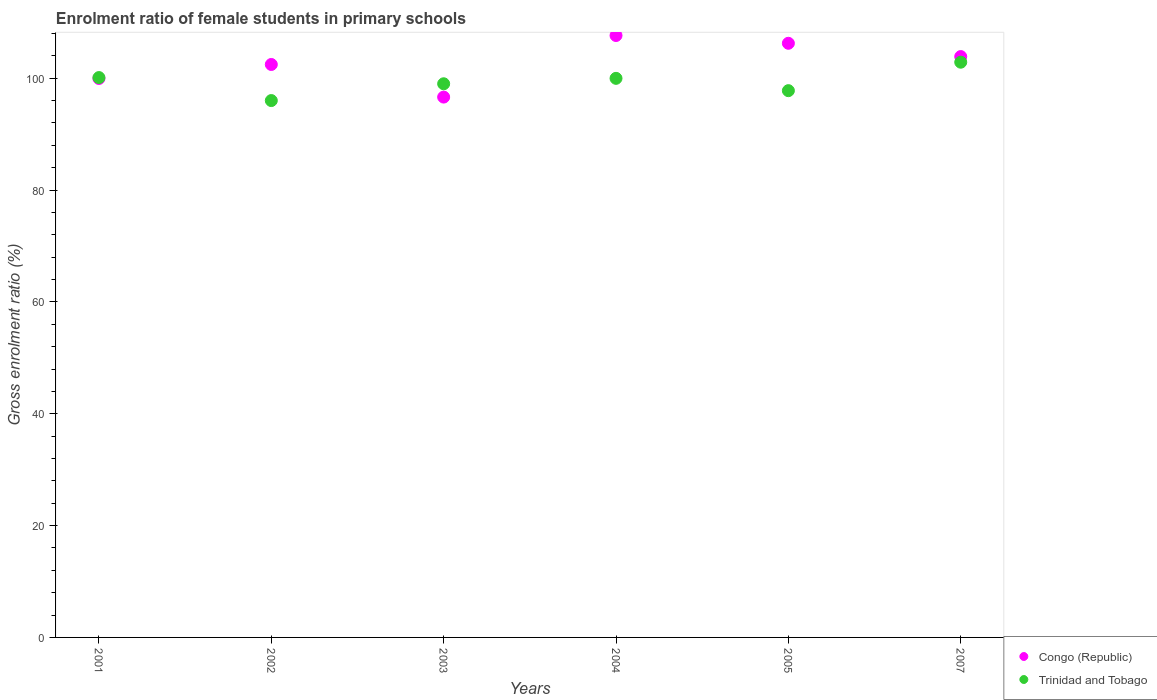What is the enrolment ratio of female students in primary schools in Trinidad and Tobago in 2004?
Provide a short and direct response. 99.98. Across all years, what is the maximum enrolment ratio of female students in primary schools in Trinidad and Tobago?
Your response must be concise. 102.87. Across all years, what is the minimum enrolment ratio of female students in primary schools in Congo (Republic)?
Offer a terse response. 96.63. In which year was the enrolment ratio of female students in primary schools in Congo (Republic) maximum?
Your response must be concise. 2004. In which year was the enrolment ratio of female students in primary schools in Congo (Republic) minimum?
Provide a succinct answer. 2003. What is the total enrolment ratio of female students in primary schools in Congo (Republic) in the graph?
Your answer should be very brief. 616.82. What is the difference between the enrolment ratio of female students in primary schools in Congo (Republic) in 2001 and that in 2003?
Your answer should be very brief. 3.33. What is the difference between the enrolment ratio of female students in primary schools in Trinidad and Tobago in 2005 and the enrolment ratio of female students in primary schools in Congo (Republic) in 2001?
Provide a succinct answer. -2.18. What is the average enrolment ratio of female students in primary schools in Congo (Republic) per year?
Keep it short and to the point. 102.8. In the year 2001, what is the difference between the enrolment ratio of female students in primary schools in Congo (Republic) and enrolment ratio of female students in primary schools in Trinidad and Tobago?
Keep it short and to the point. -0.16. What is the ratio of the enrolment ratio of female students in primary schools in Trinidad and Tobago in 2001 to that in 2003?
Offer a terse response. 1.01. What is the difference between the highest and the second highest enrolment ratio of female students in primary schools in Congo (Republic)?
Keep it short and to the point. 1.39. What is the difference between the highest and the lowest enrolment ratio of female students in primary schools in Trinidad and Tobago?
Give a very brief answer. 6.86. In how many years, is the enrolment ratio of female students in primary schools in Congo (Republic) greater than the average enrolment ratio of female students in primary schools in Congo (Republic) taken over all years?
Keep it short and to the point. 3. Is the enrolment ratio of female students in primary schools in Congo (Republic) strictly greater than the enrolment ratio of female students in primary schools in Trinidad and Tobago over the years?
Provide a short and direct response. No. Is the enrolment ratio of female students in primary schools in Congo (Republic) strictly less than the enrolment ratio of female students in primary schools in Trinidad and Tobago over the years?
Provide a short and direct response. No. How many years are there in the graph?
Ensure brevity in your answer.  6. Where does the legend appear in the graph?
Your answer should be compact. Bottom right. How many legend labels are there?
Make the answer very short. 2. How are the legend labels stacked?
Make the answer very short. Vertical. What is the title of the graph?
Your answer should be very brief. Enrolment ratio of female students in primary schools. Does "China" appear as one of the legend labels in the graph?
Your answer should be very brief. No. What is the Gross enrolment ratio (%) of Congo (Republic) in 2001?
Keep it short and to the point. 99.96. What is the Gross enrolment ratio (%) in Trinidad and Tobago in 2001?
Offer a very short reply. 100.12. What is the Gross enrolment ratio (%) in Congo (Republic) in 2002?
Provide a short and direct response. 102.46. What is the Gross enrolment ratio (%) in Trinidad and Tobago in 2002?
Offer a terse response. 96.01. What is the Gross enrolment ratio (%) of Congo (Republic) in 2003?
Offer a terse response. 96.63. What is the Gross enrolment ratio (%) in Trinidad and Tobago in 2003?
Offer a terse response. 99.01. What is the Gross enrolment ratio (%) of Congo (Republic) in 2004?
Keep it short and to the point. 107.64. What is the Gross enrolment ratio (%) of Trinidad and Tobago in 2004?
Keep it short and to the point. 99.98. What is the Gross enrolment ratio (%) of Congo (Republic) in 2005?
Ensure brevity in your answer.  106.25. What is the Gross enrolment ratio (%) in Trinidad and Tobago in 2005?
Your response must be concise. 97.78. What is the Gross enrolment ratio (%) of Congo (Republic) in 2007?
Make the answer very short. 103.88. What is the Gross enrolment ratio (%) in Trinidad and Tobago in 2007?
Make the answer very short. 102.87. Across all years, what is the maximum Gross enrolment ratio (%) of Congo (Republic)?
Provide a succinct answer. 107.64. Across all years, what is the maximum Gross enrolment ratio (%) in Trinidad and Tobago?
Offer a terse response. 102.87. Across all years, what is the minimum Gross enrolment ratio (%) of Congo (Republic)?
Give a very brief answer. 96.63. Across all years, what is the minimum Gross enrolment ratio (%) of Trinidad and Tobago?
Provide a succinct answer. 96.01. What is the total Gross enrolment ratio (%) of Congo (Republic) in the graph?
Your answer should be compact. 616.82. What is the total Gross enrolment ratio (%) of Trinidad and Tobago in the graph?
Provide a short and direct response. 595.77. What is the difference between the Gross enrolment ratio (%) in Congo (Republic) in 2001 and that in 2002?
Keep it short and to the point. -2.5. What is the difference between the Gross enrolment ratio (%) of Trinidad and Tobago in 2001 and that in 2002?
Your response must be concise. 4.11. What is the difference between the Gross enrolment ratio (%) of Congo (Republic) in 2001 and that in 2003?
Offer a very short reply. 3.33. What is the difference between the Gross enrolment ratio (%) in Trinidad and Tobago in 2001 and that in 2003?
Give a very brief answer. 1.11. What is the difference between the Gross enrolment ratio (%) of Congo (Republic) in 2001 and that in 2004?
Your answer should be very brief. -7.69. What is the difference between the Gross enrolment ratio (%) in Trinidad and Tobago in 2001 and that in 2004?
Offer a terse response. 0.14. What is the difference between the Gross enrolment ratio (%) of Congo (Republic) in 2001 and that in 2005?
Your response must be concise. -6.3. What is the difference between the Gross enrolment ratio (%) in Trinidad and Tobago in 2001 and that in 2005?
Give a very brief answer. 2.34. What is the difference between the Gross enrolment ratio (%) of Congo (Republic) in 2001 and that in 2007?
Provide a short and direct response. -3.92. What is the difference between the Gross enrolment ratio (%) of Trinidad and Tobago in 2001 and that in 2007?
Your answer should be compact. -2.75. What is the difference between the Gross enrolment ratio (%) of Congo (Republic) in 2002 and that in 2003?
Ensure brevity in your answer.  5.83. What is the difference between the Gross enrolment ratio (%) of Trinidad and Tobago in 2002 and that in 2003?
Provide a succinct answer. -3. What is the difference between the Gross enrolment ratio (%) of Congo (Republic) in 2002 and that in 2004?
Ensure brevity in your answer.  -5.18. What is the difference between the Gross enrolment ratio (%) in Trinidad and Tobago in 2002 and that in 2004?
Provide a short and direct response. -3.97. What is the difference between the Gross enrolment ratio (%) in Congo (Republic) in 2002 and that in 2005?
Provide a short and direct response. -3.79. What is the difference between the Gross enrolment ratio (%) in Trinidad and Tobago in 2002 and that in 2005?
Ensure brevity in your answer.  -1.77. What is the difference between the Gross enrolment ratio (%) in Congo (Republic) in 2002 and that in 2007?
Ensure brevity in your answer.  -1.42. What is the difference between the Gross enrolment ratio (%) of Trinidad and Tobago in 2002 and that in 2007?
Offer a very short reply. -6.86. What is the difference between the Gross enrolment ratio (%) in Congo (Republic) in 2003 and that in 2004?
Provide a short and direct response. -11.01. What is the difference between the Gross enrolment ratio (%) of Trinidad and Tobago in 2003 and that in 2004?
Your response must be concise. -0.97. What is the difference between the Gross enrolment ratio (%) of Congo (Republic) in 2003 and that in 2005?
Your answer should be very brief. -9.62. What is the difference between the Gross enrolment ratio (%) in Trinidad and Tobago in 2003 and that in 2005?
Your answer should be very brief. 1.23. What is the difference between the Gross enrolment ratio (%) of Congo (Republic) in 2003 and that in 2007?
Make the answer very short. -7.25. What is the difference between the Gross enrolment ratio (%) in Trinidad and Tobago in 2003 and that in 2007?
Provide a succinct answer. -3.86. What is the difference between the Gross enrolment ratio (%) of Congo (Republic) in 2004 and that in 2005?
Give a very brief answer. 1.39. What is the difference between the Gross enrolment ratio (%) in Trinidad and Tobago in 2004 and that in 2005?
Your answer should be very brief. 2.2. What is the difference between the Gross enrolment ratio (%) of Congo (Republic) in 2004 and that in 2007?
Ensure brevity in your answer.  3.77. What is the difference between the Gross enrolment ratio (%) of Trinidad and Tobago in 2004 and that in 2007?
Make the answer very short. -2.89. What is the difference between the Gross enrolment ratio (%) in Congo (Republic) in 2005 and that in 2007?
Keep it short and to the point. 2.38. What is the difference between the Gross enrolment ratio (%) of Trinidad and Tobago in 2005 and that in 2007?
Provide a succinct answer. -5.09. What is the difference between the Gross enrolment ratio (%) of Congo (Republic) in 2001 and the Gross enrolment ratio (%) of Trinidad and Tobago in 2002?
Give a very brief answer. 3.95. What is the difference between the Gross enrolment ratio (%) of Congo (Republic) in 2001 and the Gross enrolment ratio (%) of Trinidad and Tobago in 2003?
Provide a short and direct response. 0.94. What is the difference between the Gross enrolment ratio (%) of Congo (Republic) in 2001 and the Gross enrolment ratio (%) of Trinidad and Tobago in 2004?
Offer a terse response. -0.03. What is the difference between the Gross enrolment ratio (%) of Congo (Republic) in 2001 and the Gross enrolment ratio (%) of Trinidad and Tobago in 2005?
Ensure brevity in your answer.  2.18. What is the difference between the Gross enrolment ratio (%) in Congo (Republic) in 2001 and the Gross enrolment ratio (%) in Trinidad and Tobago in 2007?
Offer a very short reply. -2.91. What is the difference between the Gross enrolment ratio (%) of Congo (Republic) in 2002 and the Gross enrolment ratio (%) of Trinidad and Tobago in 2003?
Give a very brief answer. 3.45. What is the difference between the Gross enrolment ratio (%) of Congo (Republic) in 2002 and the Gross enrolment ratio (%) of Trinidad and Tobago in 2004?
Ensure brevity in your answer.  2.48. What is the difference between the Gross enrolment ratio (%) in Congo (Republic) in 2002 and the Gross enrolment ratio (%) in Trinidad and Tobago in 2005?
Make the answer very short. 4.68. What is the difference between the Gross enrolment ratio (%) in Congo (Republic) in 2002 and the Gross enrolment ratio (%) in Trinidad and Tobago in 2007?
Your response must be concise. -0.41. What is the difference between the Gross enrolment ratio (%) in Congo (Republic) in 2003 and the Gross enrolment ratio (%) in Trinidad and Tobago in 2004?
Offer a very short reply. -3.35. What is the difference between the Gross enrolment ratio (%) of Congo (Republic) in 2003 and the Gross enrolment ratio (%) of Trinidad and Tobago in 2005?
Give a very brief answer. -1.15. What is the difference between the Gross enrolment ratio (%) of Congo (Republic) in 2003 and the Gross enrolment ratio (%) of Trinidad and Tobago in 2007?
Give a very brief answer. -6.24. What is the difference between the Gross enrolment ratio (%) in Congo (Republic) in 2004 and the Gross enrolment ratio (%) in Trinidad and Tobago in 2005?
Your answer should be compact. 9.86. What is the difference between the Gross enrolment ratio (%) in Congo (Republic) in 2004 and the Gross enrolment ratio (%) in Trinidad and Tobago in 2007?
Offer a terse response. 4.78. What is the difference between the Gross enrolment ratio (%) in Congo (Republic) in 2005 and the Gross enrolment ratio (%) in Trinidad and Tobago in 2007?
Your answer should be compact. 3.38. What is the average Gross enrolment ratio (%) in Congo (Republic) per year?
Make the answer very short. 102.8. What is the average Gross enrolment ratio (%) of Trinidad and Tobago per year?
Your response must be concise. 99.29. In the year 2001, what is the difference between the Gross enrolment ratio (%) in Congo (Republic) and Gross enrolment ratio (%) in Trinidad and Tobago?
Offer a very short reply. -0.16. In the year 2002, what is the difference between the Gross enrolment ratio (%) of Congo (Republic) and Gross enrolment ratio (%) of Trinidad and Tobago?
Keep it short and to the point. 6.45. In the year 2003, what is the difference between the Gross enrolment ratio (%) of Congo (Republic) and Gross enrolment ratio (%) of Trinidad and Tobago?
Provide a short and direct response. -2.38. In the year 2004, what is the difference between the Gross enrolment ratio (%) of Congo (Republic) and Gross enrolment ratio (%) of Trinidad and Tobago?
Your response must be concise. 7.66. In the year 2005, what is the difference between the Gross enrolment ratio (%) in Congo (Republic) and Gross enrolment ratio (%) in Trinidad and Tobago?
Make the answer very short. 8.47. In the year 2007, what is the difference between the Gross enrolment ratio (%) of Congo (Republic) and Gross enrolment ratio (%) of Trinidad and Tobago?
Ensure brevity in your answer.  1.01. What is the ratio of the Gross enrolment ratio (%) of Congo (Republic) in 2001 to that in 2002?
Your response must be concise. 0.98. What is the ratio of the Gross enrolment ratio (%) of Trinidad and Tobago in 2001 to that in 2002?
Offer a terse response. 1.04. What is the ratio of the Gross enrolment ratio (%) of Congo (Republic) in 2001 to that in 2003?
Keep it short and to the point. 1.03. What is the ratio of the Gross enrolment ratio (%) of Trinidad and Tobago in 2001 to that in 2003?
Provide a succinct answer. 1.01. What is the ratio of the Gross enrolment ratio (%) in Congo (Republic) in 2001 to that in 2004?
Give a very brief answer. 0.93. What is the ratio of the Gross enrolment ratio (%) in Congo (Republic) in 2001 to that in 2005?
Offer a very short reply. 0.94. What is the ratio of the Gross enrolment ratio (%) in Trinidad and Tobago in 2001 to that in 2005?
Offer a very short reply. 1.02. What is the ratio of the Gross enrolment ratio (%) of Congo (Republic) in 2001 to that in 2007?
Provide a short and direct response. 0.96. What is the ratio of the Gross enrolment ratio (%) in Trinidad and Tobago in 2001 to that in 2007?
Ensure brevity in your answer.  0.97. What is the ratio of the Gross enrolment ratio (%) in Congo (Republic) in 2002 to that in 2003?
Give a very brief answer. 1.06. What is the ratio of the Gross enrolment ratio (%) of Trinidad and Tobago in 2002 to that in 2003?
Your response must be concise. 0.97. What is the ratio of the Gross enrolment ratio (%) of Congo (Republic) in 2002 to that in 2004?
Make the answer very short. 0.95. What is the ratio of the Gross enrolment ratio (%) of Trinidad and Tobago in 2002 to that in 2004?
Keep it short and to the point. 0.96. What is the ratio of the Gross enrolment ratio (%) of Trinidad and Tobago in 2002 to that in 2005?
Your answer should be very brief. 0.98. What is the ratio of the Gross enrolment ratio (%) in Congo (Republic) in 2002 to that in 2007?
Make the answer very short. 0.99. What is the ratio of the Gross enrolment ratio (%) in Congo (Republic) in 2003 to that in 2004?
Offer a very short reply. 0.9. What is the ratio of the Gross enrolment ratio (%) of Trinidad and Tobago in 2003 to that in 2004?
Your answer should be very brief. 0.99. What is the ratio of the Gross enrolment ratio (%) in Congo (Republic) in 2003 to that in 2005?
Ensure brevity in your answer.  0.91. What is the ratio of the Gross enrolment ratio (%) of Trinidad and Tobago in 2003 to that in 2005?
Provide a short and direct response. 1.01. What is the ratio of the Gross enrolment ratio (%) of Congo (Republic) in 2003 to that in 2007?
Provide a succinct answer. 0.93. What is the ratio of the Gross enrolment ratio (%) of Trinidad and Tobago in 2003 to that in 2007?
Offer a very short reply. 0.96. What is the ratio of the Gross enrolment ratio (%) of Congo (Republic) in 2004 to that in 2005?
Your answer should be very brief. 1.01. What is the ratio of the Gross enrolment ratio (%) of Trinidad and Tobago in 2004 to that in 2005?
Provide a succinct answer. 1.02. What is the ratio of the Gross enrolment ratio (%) of Congo (Republic) in 2004 to that in 2007?
Provide a short and direct response. 1.04. What is the ratio of the Gross enrolment ratio (%) in Trinidad and Tobago in 2004 to that in 2007?
Provide a succinct answer. 0.97. What is the ratio of the Gross enrolment ratio (%) of Congo (Republic) in 2005 to that in 2007?
Keep it short and to the point. 1.02. What is the ratio of the Gross enrolment ratio (%) in Trinidad and Tobago in 2005 to that in 2007?
Provide a succinct answer. 0.95. What is the difference between the highest and the second highest Gross enrolment ratio (%) in Congo (Republic)?
Your answer should be very brief. 1.39. What is the difference between the highest and the second highest Gross enrolment ratio (%) in Trinidad and Tobago?
Your answer should be compact. 2.75. What is the difference between the highest and the lowest Gross enrolment ratio (%) in Congo (Republic)?
Provide a short and direct response. 11.01. What is the difference between the highest and the lowest Gross enrolment ratio (%) in Trinidad and Tobago?
Your response must be concise. 6.86. 